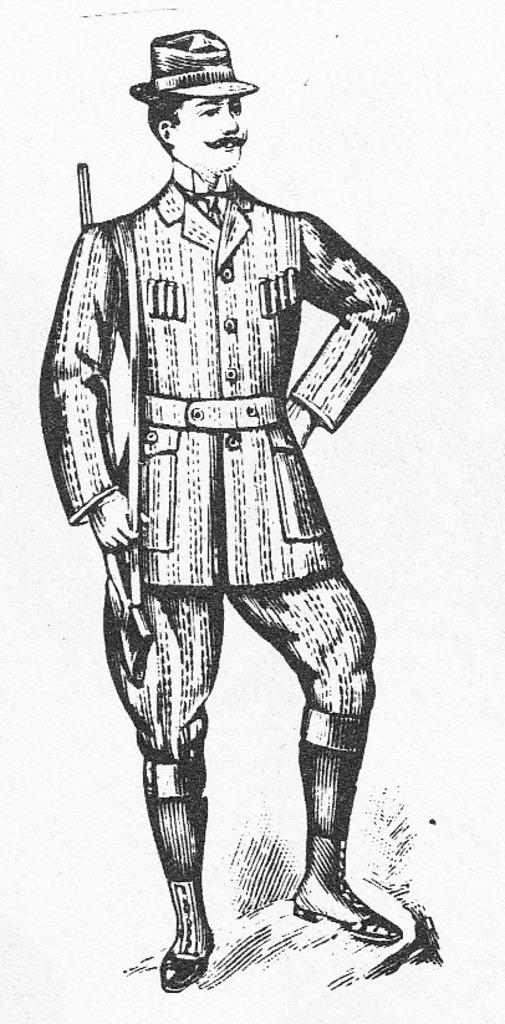Who is present in the image? There is a man in the image. What is the man wearing on his head? The man is wearing a cap. What is the man holding in his hand? The man is holding a gun belt in his hand. What type of steel is visible in the image? There is no steel present in the image. How does the man's knee look in the image? The image does not show the man's knee, so it cannot be described. 